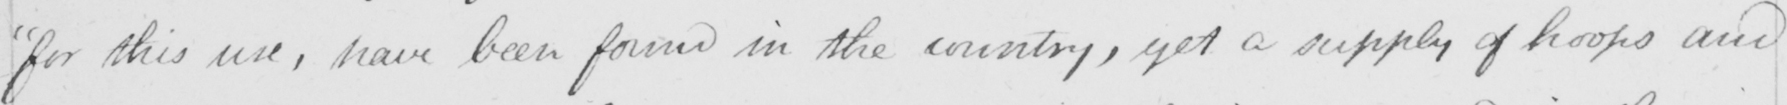Please provide the text content of this handwritten line. for this use , have been found in the country , yet a supply of hoops and 